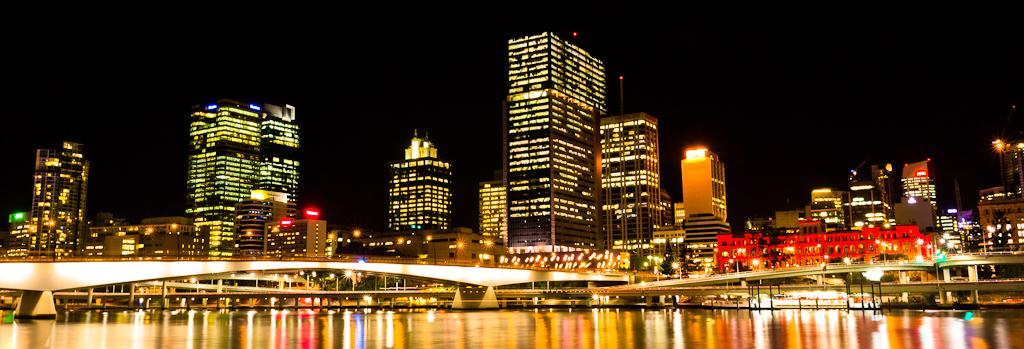What can be seen in the foreground of the image? There is water in the foreground of the image. What structures are present in the image? There are bridges in the image. What type of buildings can be seen in the background of the image? There are tower buildings in the background of the image. How would you describe the sky in the image? The sky is dark in the image. What type of toothpaste is being used to clean the jail in the image? There is no jail or toothpaste present in the image. What phase is the moon in during the scene depicted in the image? There is no moon visible in the image. 